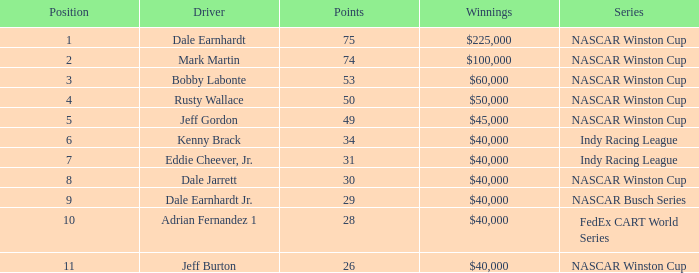What series was bobby labonte a driver in? NASCAR Winston Cup. 